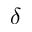Convert formula to latex. <formula><loc_0><loc_0><loc_500><loc_500>\delta</formula> 